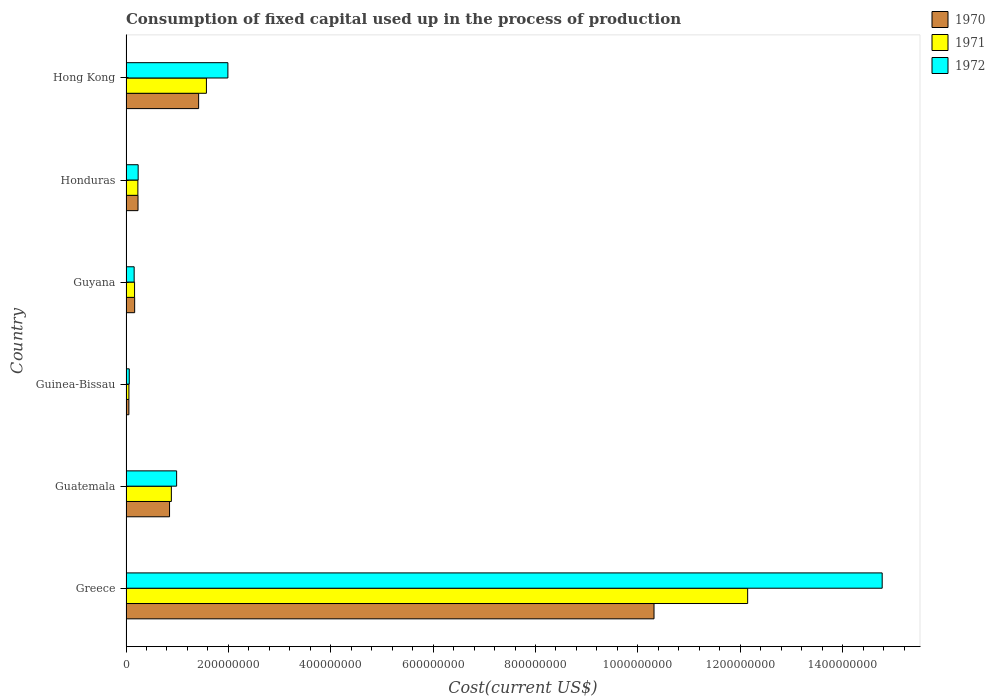How many groups of bars are there?
Provide a succinct answer. 6. Are the number of bars per tick equal to the number of legend labels?
Provide a succinct answer. Yes. What is the label of the 4th group of bars from the top?
Provide a short and direct response. Guinea-Bissau. What is the amount consumed in the process of production in 1970 in Greece?
Provide a short and direct response. 1.03e+09. Across all countries, what is the maximum amount consumed in the process of production in 1971?
Your response must be concise. 1.21e+09. Across all countries, what is the minimum amount consumed in the process of production in 1972?
Your answer should be compact. 6.34e+06. In which country was the amount consumed in the process of production in 1972 minimum?
Your response must be concise. Guinea-Bissau. What is the total amount consumed in the process of production in 1970 in the graph?
Make the answer very short. 1.30e+09. What is the difference between the amount consumed in the process of production in 1971 in Guinea-Bissau and that in Hong Kong?
Offer a very short reply. -1.51e+08. What is the difference between the amount consumed in the process of production in 1970 in Guatemala and the amount consumed in the process of production in 1971 in Honduras?
Your answer should be very brief. 6.19e+07. What is the average amount consumed in the process of production in 1970 per country?
Offer a very short reply. 2.17e+08. What is the ratio of the amount consumed in the process of production in 1972 in Guatemala to that in Guyana?
Ensure brevity in your answer.  6.22. What is the difference between the highest and the second highest amount consumed in the process of production in 1971?
Keep it short and to the point. 1.06e+09. What is the difference between the highest and the lowest amount consumed in the process of production in 1971?
Your answer should be compact. 1.21e+09. Is the sum of the amount consumed in the process of production in 1972 in Greece and Guyana greater than the maximum amount consumed in the process of production in 1970 across all countries?
Provide a short and direct response. Yes. What does the 1st bar from the bottom in Honduras represents?
Offer a very short reply. 1970. Is it the case that in every country, the sum of the amount consumed in the process of production in 1970 and amount consumed in the process of production in 1972 is greater than the amount consumed in the process of production in 1971?
Give a very brief answer. Yes. How many bars are there?
Offer a terse response. 18. How many countries are there in the graph?
Keep it short and to the point. 6. What is the title of the graph?
Provide a short and direct response. Consumption of fixed capital used up in the process of production. Does "1993" appear as one of the legend labels in the graph?
Ensure brevity in your answer.  No. What is the label or title of the X-axis?
Ensure brevity in your answer.  Cost(current US$). What is the Cost(current US$) in 1970 in Greece?
Make the answer very short. 1.03e+09. What is the Cost(current US$) in 1971 in Greece?
Provide a succinct answer. 1.21e+09. What is the Cost(current US$) in 1972 in Greece?
Your answer should be compact. 1.48e+09. What is the Cost(current US$) in 1970 in Guatemala?
Your answer should be compact. 8.51e+07. What is the Cost(current US$) of 1971 in Guatemala?
Your answer should be compact. 8.86e+07. What is the Cost(current US$) of 1972 in Guatemala?
Make the answer very short. 9.89e+07. What is the Cost(current US$) of 1970 in Guinea-Bissau?
Keep it short and to the point. 5.61e+06. What is the Cost(current US$) in 1971 in Guinea-Bissau?
Your response must be concise. 5.67e+06. What is the Cost(current US$) in 1972 in Guinea-Bissau?
Your response must be concise. 6.34e+06. What is the Cost(current US$) in 1970 in Guyana?
Offer a terse response. 1.69e+07. What is the Cost(current US$) in 1971 in Guyana?
Your response must be concise. 1.67e+07. What is the Cost(current US$) of 1972 in Guyana?
Keep it short and to the point. 1.59e+07. What is the Cost(current US$) in 1970 in Honduras?
Ensure brevity in your answer.  2.34e+07. What is the Cost(current US$) of 1971 in Honduras?
Your answer should be compact. 2.32e+07. What is the Cost(current US$) in 1972 in Honduras?
Ensure brevity in your answer.  2.37e+07. What is the Cost(current US$) of 1970 in Hong Kong?
Provide a succinct answer. 1.42e+08. What is the Cost(current US$) of 1971 in Hong Kong?
Give a very brief answer. 1.57e+08. What is the Cost(current US$) of 1972 in Hong Kong?
Ensure brevity in your answer.  1.99e+08. Across all countries, what is the maximum Cost(current US$) in 1970?
Your response must be concise. 1.03e+09. Across all countries, what is the maximum Cost(current US$) in 1971?
Offer a very short reply. 1.21e+09. Across all countries, what is the maximum Cost(current US$) of 1972?
Your response must be concise. 1.48e+09. Across all countries, what is the minimum Cost(current US$) in 1970?
Provide a short and direct response. 5.61e+06. Across all countries, what is the minimum Cost(current US$) in 1971?
Provide a short and direct response. 5.67e+06. Across all countries, what is the minimum Cost(current US$) in 1972?
Your response must be concise. 6.34e+06. What is the total Cost(current US$) in 1970 in the graph?
Provide a succinct answer. 1.30e+09. What is the total Cost(current US$) in 1971 in the graph?
Your response must be concise. 1.51e+09. What is the total Cost(current US$) in 1972 in the graph?
Provide a succinct answer. 1.82e+09. What is the difference between the Cost(current US$) in 1970 in Greece and that in Guatemala?
Give a very brief answer. 9.47e+08. What is the difference between the Cost(current US$) of 1971 in Greece and that in Guatemala?
Offer a very short reply. 1.13e+09. What is the difference between the Cost(current US$) of 1972 in Greece and that in Guatemala?
Your answer should be compact. 1.38e+09. What is the difference between the Cost(current US$) in 1970 in Greece and that in Guinea-Bissau?
Your answer should be compact. 1.03e+09. What is the difference between the Cost(current US$) in 1971 in Greece and that in Guinea-Bissau?
Ensure brevity in your answer.  1.21e+09. What is the difference between the Cost(current US$) of 1972 in Greece and that in Guinea-Bissau?
Your answer should be compact. 1.47e+09. What is the difference between the Cost(current US$) in 1970 in Greece and that in Guyana?
Give a very brief answer. 1.01e+09. What is the difference between the Cost(current US$) in 1971 in Greece and that in Guyana?
Provide a succinct answer. 1.20e+09. What is the difference between the Cost(current US$) in 1972 in Greece and that in Guyana?
Provide a succinct answer. 1.46e+09. What is the difference between the Cost(current US$) of 1970 in Greece and that in Honduras?
Provide a succinct answer. 1.01e+09. What is the difference between the Cost(current US$) in 1971 in Greece and that in Honduras?
Your response must be concise. 1.19e+09. What is the difference between the Cost(current US$) in 1972 in Greece and that in Honduras?
Keep it short and to the point. 1.45e+09. What is the difference between the Cost(current US$) of 1970 in Greece and that in Hong Kong?
Give a very brief answer. 8.90e+08. What is the difference between the Cost(current US$) of 1971 in Greece and that in Hong Kong?
Provide a succinct answer. 1.06e+09. What is the difference between the Cost(current US$) of 1972 in Greece and that in Hong Kong?
Keep it short and to the point. 1.28e+09. What is the difference between the Cost(current US$) of 1970 in Guatemala and that in Guinea-Bissau?
Your response must be concise. 7.94e+07. What is the difference between the Cost(current US$) of 1971 in Guatemala and that in Guinea-Bissau?
Provide a short and direct response. 8.29e+07. What is the difference between the Cost(current US$) of 1972 in Guatemala and that in Guinea-Bissau?
Keep it short and to the point. 9.25e+07. What is the difference between the Cost(current US$) of 1970 in Guatemala and that in Guyana?
Offer a very short reply. 6.82e+07. What is the difference between the Cost(current US$) in 1971 in Guatemala and that in Guyana?
Offer a very short reply. 7.19e+07. What is the difference between the Cost(current US$) in 1972 in Guatemala and that in Guyana?
Give a very brief answer. 8.30e+07. What is the difference between the Cost(current US$) in 1970 in Guatemala and that in Honduras?
Keep it short and to the point. 6.16e+07. What is the difference between the Cost(current US$) in 1971 in Guatemala and that in Honduras?
Offer a very short reply. 6.54e+07. What is the difference between the Cost(current US$) in 1972 in Guatemala and that in Honduras?
Keep it short and to the point. 7.51e+07. What is the difference between the Cost(current US$) in 1970 in Guatemala and that in Hong Kong?
Keep it short and to the point. -5.68e+07. What is the difference between the Cost(current US$) of 1971 in Guatemala and that in Hong Kong?
Make the answer very short. -6.85e+07. What is the difference between the Cost(current US$) of 1972 in Guatemala and that in Hong Kong?
Offer a terse response. -1.00e+08. What is the difference between the Cost(current US$) in 1970 in Guinea-Bissau and that in Guyana?
Ensure brevity in your answer.  -1.13e+07. What is the difference between the Cost(current US$) in 1971 in Guinea-Bissau and that in Guyana?
Provide a short and direct response. -1.10e+07. What is the difference between the Cost(current US$) in 1972 in Guinea-Bissau and that in Guyana?
Offer a very short reply. -9.56e+06. What is the difference between the Cost(current US$) of 1970 in Guinea-Bissau and that in Honduras?
Ensure brevity in your answer.  -1.78e+07. What is the difference between the Cost(current US$) in 1971 in Guinea-Bissau and that in Honduras?
Your answer should be very brief. -1.75e+07. What is the difference between the Cost(current US$) of 1972 in Guinea-Bissau and that in Honduras?
Your answer should be compact. -1.74e+07. What is the difference between the Cost(current US$) of 1970 in Guinea-Bissau and that in Hong Kong?
Provide a succinct answer. -1.36e+08. What is the difference between the Cost(current US$) of 1971 in Guinea-Bissau and that in Hong Kong?
Your answer should be very brief. -1.51e+08. What is the difference between the Cost(current US$) in 1972 in Guinea-Bissau and that in Hong Kong?
Make the answer very short. -1.93e+08. What is the difference between the Cost(current US$) in 1970 in Guyana and that in Honduras?
Offer a very short reply. -6.54e+06. What is the difference between the Cost(current US$) in 1971 in Guyana and that in Honduras?
Offer a very short reply. -6.46e+06. What is the difference between the Cost(current US$) of 1972 in Guyana and that in Honduras?
Your answer should be very brief. -7.83e+06. What is the difference between the Cost(current US$) in 1970 in Guyana and that in Hong Kong?
Offer a very short reply. -1.25e+08. What is the difference between the Cost(current US$) in 1971 in Guyana and that in Hong Kong?
Provide a short and direct response. -1.40e+08. What is the difference between the Cost(current US$) of 1972 in Guyana and that in Hong Kong?
Your answer should be very brief. -1.83e+08. What is the difference between the Cost(current US$) in 1970 in Honduras and that in Hong Kong?
Provide a succinct answer. -1.18e+08. What is the difference between the Cost(current US$) of 1971 in Honduras and that in Hong Kong?
Your response must be concise. -1.34e+08. What is the difference between the Cost(current US$) of 1972 in Honduras and that in Hong Kong?
Make the answer very short. -1.75e+08. What is the difference between the Cost(current US$) of 1970 in Greece and the Cost(current US$) of 1971 in Guatemala?
Give a very brief answer. 9.43e+08. What is the difference between the Cost(current US$) in 1970 in Greece and the Cost(current US$) in 1972 in Guatemala?
Your answer should be very brief. 9.33e+08. What is the difference between the Cost(current US$) of 1971 in Greece and the Cost(current US$) of 1972 in Guatemala?
Offer a terse response. 1.12e+09. What is the difference between the Cost(current US$) of 1970 in Greece and the Cost(current US$) of 1971 in Guinea-Bissau?
Offer a very short reply. 1.03e+09. What is the difference between the Cost(current US$) in 1970 in Greece and the Cost(current US$) in 1972 in Guinea-Bissau?
Offer a very short reply. 1.03e+09. What is the difference between the Cost(current US$) in 1971 in Greece and the Cost(current US$) in 1972 in Guinea-Bissau?
Your response must be concise. 1.21e+09. What is the difference between the Cost(current US$) of 1970 in Greece and the Cost(current US$) of 1971 in Guyana?
Offer a very short reply. 1.01e+09. What is the difference between the Cost(current US$) of 1970 in Greece and the Cost(current US$) of 1972 in Guyana?
Keep it short and to the point. 1.02e+09. What is the difference between the Cost(current US$) in 1971 in Greece and the Cost(current US$) in 1972 in Guyana?
Your answer should be compact. 1.20e+09. What is the difference between the Cost(current US$) of 1970 in Greece and the Cost(current US$) of 1971 in Honduras?
Your answer should be very brief. 1.01e+09. What is the difference between the Cost(current US$) in 1970 in Greece and the Cost(current US$) in 1972 in Honduras?
Provide a short and direct response. 1.01e+09. What is the difference between the Cost(current US$) in 1971 in Greece and the Cost(current US$) in 1972 in Honduras?
Keep it short and to the point. 1.19e+09. What is the difference between the Cost(current US$) of 1970 in Greece and the Cost(current US$) of 1971 in Hong Kong?
Give a very brief answer. 8.75e+08. What is the difference between the Cost(current US$) in 1970 in Greece and the Cost(current US$) in 1972 in Hong Kong?
Make the answer very short. 8.33e+08. What is the difference between the Cost(current US$) of 1971 in Greece and the Cost(current US$) of 1972 in Hong Kong?
Provide a short and direct response. 1.02e+09. What is the difference between the Cost(current US$) in 1970 in Guatemala and the Cost(current US$) in 1971 in Guinea-Bissau?
Offer a terse response. 7.94e+07. What is the difference between the Cost(current US$) in 1970 in Guatemala and the Cost(current US$) in 1972 in Guinea-Bissau?
Your answer should be very brief. 7.87e+07. What is the difference between the Cost(current US$) of 1971 in Guatemala and the Cost(current US$) of 1972 in Guinea-Bissau?
Provide a succinct answer. 8.23e+07. What is the difference between the Cost(current US$) in 1970 in Guatemala and the Cost(current US$) in 1971 in Guyana?
Offer a terse response. 6.84e+07. What is the difference between the Cost(current US$) of 1970 in Guatemala and the Cost(current US$) of 1972 in Guyana?
Your answer should be compact. 6.92e+07. What is the difference between the Cost(current US$) of 1971 in Guatemala and the Cost(current US$) of 1972 in Guyana?
Provide a short and direct response. 7.27e+07. What is the difference between the Cost(current US$) of 1970 in Guatemala and the Cost(current US$) of 1971 in Honduras?
Your response must be concise. 6.19e+07. What is the difference between the Cost(current US$) of 1970 in Guatemala and the Cost(current US$) of 1972 in Honduras?
Ensure brevity in your answer.  6.13e+07. What is the difference between the Cost(current US$) in 1971 in Guatemala and the Cost(current US$) in 1972 in Honduras?
Offer a terse response. 6.49e+07. What is the difference between the Cost(current US$) in 1970 in Guatemala and the Cost(current US$) in 1971 in Hong Kong?
Offer a very short reply. -7.20e+07. What is the difference between the Cost(current US$) in 1970 in Guatemala and the Cost(current US$) in 1972 in Hong Kong?
Make the answer very short. -1.14e+08. What is the difference between the Cost(current US$) in 1971 in Guatemala and the Cost(current US$) in 1972 in Hong Kong?
Offer a very short reply. -1.10e+08. What is the difference between the Cost(current US$) in 1970 in Guinea-Bissau and the Cost(current US$) in 1971 in Guyana?
Offer a very short reply. -1.11e+07. What is the difference between the Cost(current US$) of 1970 in Guinea-Bissau and the Cost(current US$) of 1972 in Guyana?
Give a very brief answer. -1.03e+07. What is the difference between the Cost(current US$) in 1971 in Guinea-Bissau and the Cost(current US$) in 1972 in Guyana?
Make the answer very short. -1.02e+07. What is the difference between the Cost(current US$) of 1970 in Guinea-Bissau and the Cost(current US$) of 1971 in Honduras?
Provide a succinct answer. -1.76e+07. What is the difference between the Cost(current US$) in 1970 in Guinea-Bissau and the Cost(current US$) in 1972 in Honduras?
Ensure brevity in your answer.  -1.81e+07. What is the difference between the Cost(current US$) in 1971 in Guinea-Bissau and the Cost(current US$) in 1972 in Honduras?
Provide a short and direct response. -1.81e+07. What is the difference between the Cost(current US$) in 1970 in Guinea-Bissau and the Cost(current US$) in 1971 in Hong Kong?
Your response must be concise. -1.51e+08. What is the difference between the Cost(current US$) in 1970 in Guinea-Bissau and the Cost(current US$) in 1972 in Hong Kong?
Provide a short and direct response. -1.93e+08. What is the difference between the Cost(current US$) in 1971 in Guinea-Bissau and the Cost(current US$) in 1972 in Hong Kong?
Offer a terse response. -1.93e+08. What is the difference between the Cost(current US$) of 1970 in Guyana and the Cost(current US$) of 1971 in Honduras?
Your answer should be compact. -6.26e+06. What is the difference between the Cost(current US$) in 1970 in Guyana and the Cost(current US$) in 1972 in Honduras?
Keep it short and to the point. -6.83e+06. What is the difference between the Cost(current US$) in 1971 in Guyana and the Cost(current US$) in 1972 in Honduras?
Provide a succinct answer. -7.03e+06. What is the difference between the Cost(current US$) in 1970 in Guyana and the Cost(current US$) in 1971 in Hong Kong?
Give a very brief answer. -1.40e+08. What is the difference between the Cost(current US$) of 1970 in Guyana and the Cost(current US$) of 1972 in Hong Kong?
Your answer should be compact. -1.82e+08. What is the difference between the Cost(current US$) of 1971 in Guyana and the Cost(current US$) of 1972 in Hong Kong?
Offer a terse response. -1.82e+08. What is the difference between the Cost(current US$) of 1970 in Honduras and the Cost(current US$) of 1971 in Hong Kong?
Make the answer very short. -1.34e+08. What is the difference between the Cost(current US$) of 1970 in Honduras and the Cost(current US$) of 1972 in Hong Kong?
Provide a short and direct response. -1.76e+08. What is the difference between the Cost(current US$) in 1971 in Honduras and the Cost(current US$) in 1972 in Hong Kong?
Offer a very short reply. -1.76e+08. What is the average Cost(current US$) of 1970 per country?
Your answer should be compact. 2.17e+08. What is the average Cost(current US$) in 1971 per country?
Provide a short and direct response. 2.51e+08. What is the average Cost(current US$) of 1972 per country?
Provide a succinct answer. 3.04e+08. What is the difference between the Cost(current US$) of 1970 and Cost(current US$) of 1971 in Greece?
Give a very brief answer. -1.83e+08. What is the difference between the Cost(current US$) of 1970 and Cost(current US$) of 1972 in Greece?
Provide a succinct answer. -4.46e+08. What is the difference between the Cost(current US$) of 1971 and Cost(current US$) of 1972 in Greece?
Make the answer very short. -2.63e+08. What is the difference between the Cost(current US$) in 1970 and Cost(current US$) in 1971 in Guatemala?
Offer a terse response. -3.54e+06. What is the difference between the Cost(current US$) of 1970 and Cost(current US$) of 1972 in Guatemala?
Provide a succinct answer. -1.38e+07. What is the difference between the Cost(current US$) in 1971 and Cost(current US$) in 1972 in Guatemala?
Provide a succinct answer. -1.03e+07. What is the difference between the Cost(current US$) of 1970 and Cost(current US$) of 1971 in Guinea-Bissau?
Offer a terse response. -6.59e+04. What is the difference between the Cost(current US$) of 1970 and Cost(current US$) of 1972 in Guinea-Bissau?
Give a very brief answer. -7.37e+05. What is the difference between the Cost(current US$) of 1971 and Cost(current US$) of 1972 in Guinea-Bissau?
Make the answer very short. -6.71e+05. What is the difference between the Cost(current US$) in 1970 and Cost(current US$) in 1971 in Guyana?
Give a very brief answer. 2.00e+05. What is the difference between the Cost(current US$) of 1970 and Cost(current US$) of 1972 in Guyana?
Give a very brief answer. 9.95e+05. What is the difference between the Cost(current US$) of 1971 and Cost(current US$) of 1972 in Guyana?
Your answer should be compact. 7.95e+05. What is the difference between the Cost(current US$) in 1970 and Cost(current US$) in 1971 in Honduras?
Your response must be concise. 2.75e+05. What is the difference between the Cost(current US$) of 1970 and Cost(current US$) of 1972 in Honduras?
Offer a terse response. -2.98e+05. What is the difference between the Cost(current US$) of 1971 and Cost(current US$) of 1972 in Honduras?
Your answer should be compact. -5.73e+05. What is the difference between the Cost(current US$) in 1970 and Cost(current US$) in 1971 in Hong Kong?
Keep it short and to the point. -1.52e+07. What is the difference between the Cost(current US$) of 1970 and Cost(current US$) of 1972 in Hong Kong?
Keep it short and to the point. -5.72e+07. What is the difference between the Cost(current US$) of 1971 and Cost(current US$) of 1972 in Hong Kong?
Your answer should be very brief. -4.20e+07. What is the ratio of the Cost(current US$) in 1970 in Greece to that in Guatemala?
Provide a short and direct response. 12.13. What is the ratio of the Cost(current US$) of 1971 in Greece to that in Guatemala?
Provide a short and direct response. 13.71. What is the ratio of the Cost(current US$) in 1972 in Greece to that in Guatemala?
Ensure brevity in your answer.  14.94. What is the ratio of the Cost(current US$) of 1970 in Greece to that in Guinea-Bissau?
Offer a terse response. 183.97. What is the ratio of the Cost(current US$) of 1971 in Greece to that in Guinea-Bissau?
Keep it short and to the point. 214.07. What is the ratio of the Cost(current US$) in 1972 in Greece to that in Guinea-Bissau?
Ensure brevity in your answer.  232.85. What is the ratio of the Cost(current US$) of 1970 in Greece to that in Guyana?
Your response must be concise. 61.04. What is the ratio of the Cost(current US$) in 1971 in Greece to that in Guyana?
Ensure brevity in your answer.  72.73. What is the ratio of the Cost(current US$) of 1972 in Greece to that in Guyana?
Your answer should be very brief. 92.89. What is the ratio of the Cost(current US$) of 1970 in Greece to that in Honduras?
Your response must be concise. 44.02. What is the ratio of the Cost(current US$) of 1971 in Greece to that in Honduras?
Your response must be concise. 52.44. What is the ratio of the Cost(current US$) of 1972 in Greece to that in Honduras?
Offer a terse response. 62.25. What is the ratio of the Cost(current US$) of 1970 in Greece to that in Hong Kong?
Make the answer very short. 7.27. What is the ratio of the Cost(current US$) in 1971 in Greece to that in Hong Kong?
Provide a succinct answer. 7.73. What is the ratio of the Cost(current US$) in 1972 in Greece to that in Hong Kong?
Give a very brief answer. 7.42. What is the ratio of the Cost(current US$) of 1970 in Guatemala to that in Guinea-Bissau?
Your answer should be very brief. 15.17. What is the ratio of the Cost(current US$) in 1971 in Guatemala to that in Guinea-Bissau?
Make the answer very short. 15.62. What is the ratio of the Cost(current US$) in 1972 in Guatemala to that in Guinea-Bissau?
Your answer should be compact. 15.58. What is the ratio of the Cost(current US$) of 1970 in Guatemala to that in Guyana?
Your answer should be compact. 5.03. What is the ratio of the Cost(current US$) in 1971 in Guatemala to that in Guyana?
Keep it short and to the point. 5.31. What is the ratio of the Cost(current US$) in 1972 in Guatemala to that in Guyana?
Offer a very short reply. 6.22. What is the ratio of the Cost(current US$) in 1970 in Guatemala to that in Honduras?
Offer a very short reply. 3.63. What is the ratio of the Cost(current US$) in 1971 in Guatemala to that in Honduras?
Make the answer very short. 3.83. What is the ratio of the Cost(current US$) of 1972 in Guatemala to that in Honduras?
Your response must be concise. 4.17. What is the ratio of the Cost(current US$) of 1970 in Guatemala to that in Hong Kong?
Give a very brief answer. 0.6. What is the ratio of the Cost(current US$) in 1971 in Guatemala to that in Hong Kong?
Give a very brief answer. 0.56. What is the ratio of the Cost(current US$) of 1972 in Guatemala to that in Hong Kong?
Offer a terse response. 0.5. What is the ratio of the Cost(current US$) in 1970 in Guinea-Bissau to that in Guyana?
Make the answer very short. 0.33. What is the ratio of the Cost(current US$) of 1971 in Guinea-Bissau to that in Guyana?
Your answer should be compact. 0.34. What is the ratio of the Cost(current US$) in 1972 in Guinea-Bissau to that in Guyana?
Offer a very short reply. 0.4. What is the ratio of the Cost(current US$) in 1970 in Guinea-Bissau to that in Honduras?
Your answer should be very brief. 0.24. What is the ratio of the Cost(current US$) of 1971 in Guinea-Bissau to that in Honduras?
Offer a terse response. 0.24. What is the ratio of the Cost(current US$) in 1972 in Guinea-Bissau to that in Honduras?
Offer a terse response. 0.27. What is the ratio of the Cost(current US$) of 1970 in Guinea-Bissau to that in Hong Kong?
Give a very brief answer. 0.04. What is the ratio of the Cost(current US$) in 1971 in Guinea-Bissau to that in Hong Kong?
Your answer should be compact. 0.04. What is the ratio of the Cost(current US$) of 1972 in Guinea-Bissau to that in Hong Kong?
Give a very brief answer. 0.03. What is the ratio of the Cost(current US$) in 1970 in Guyana to that in Honduras?
Provide a short and direct response. 0.72. What is the ratio of the Cost(current US$) of 1971 in Guyana to that in Honduras?
Your answer should be very brief. 0.72. What is the ratio of the Cost(current US$) of 1972 in Guyana to that in Honduras?
Keep it short and to the point. 0.67. What is the ratio of the Cost(current US$) of 1970 in Guyana to that in Hong Kong?
Your answer should be very brief. 0.12. What is the ratio of the Cost(current US$) in 1971 in Guyana to that in Hong Kong?
Provide a short and direct response. 0.11. What is the ratio of the Cost(current US$) of 1972 in Guyana to that in Hong Kong?
Your answer should be very brief. 0.08. What is the ratio of the Cost(current US$) of 1970 in Honduras to that in Hong Kong?
Provide a succinct answer. 0.17. What is the ratio of the Cost(current US$) of 1971 in Honduras to that in Hong Kong?
Ensure brevity in your answer.  0.15. What is the ratio of the Cost(current US$) in 1972 in Honduras to that in Hong Kong?
Provide a succinct answer. 0.12. What is the difference between the highest and the second highest Cost(current US$) of 1970?
Your response must be concise. 8.90e+08. What is the difference between the highest and the second highest Cost(current US$) of 1971?
Offer a terse response. 1.06e+09. What is the difference between the highest and the second highest Cost(current US$) in 1972?
Ensure brevity in your answer.  1.28e+09. What is the difference between the highest and the lowest Cost(current US$) in 1970?
Give a very brief answer. 1.03e+09. What is the difference between the highest and the lowest Cost(current US$) in 1971?
Keep it short and to the point. 1.21e+09. What is the difference between the highest and the lowest Cost(current US$) in 1972?
Provide a succinct answer. 1.47e+09. 